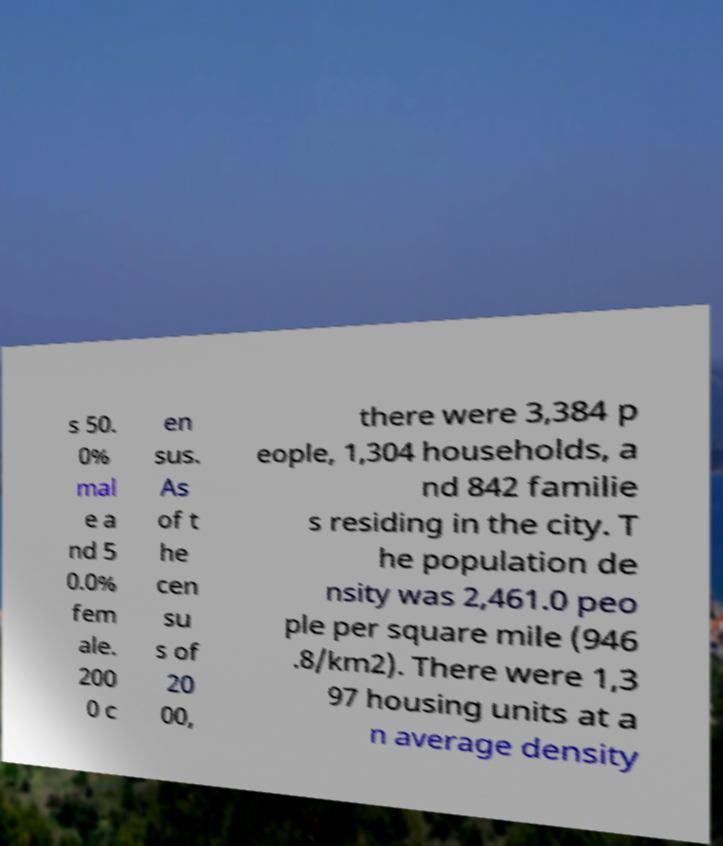Could you extract and type out the text from this image? s 50. 0% mal e a nd 5 0.0% fem ale. 200 0 c en sus. As of t he cen su s of 20 00, there were 3,384 p eople, 1,304 households, a nd 842 familie s residing in the city. T he population de nsity was 2,461.0 peo ple per square mile (946 .8/km2). There were 1,3 97 housing units at a n average density 